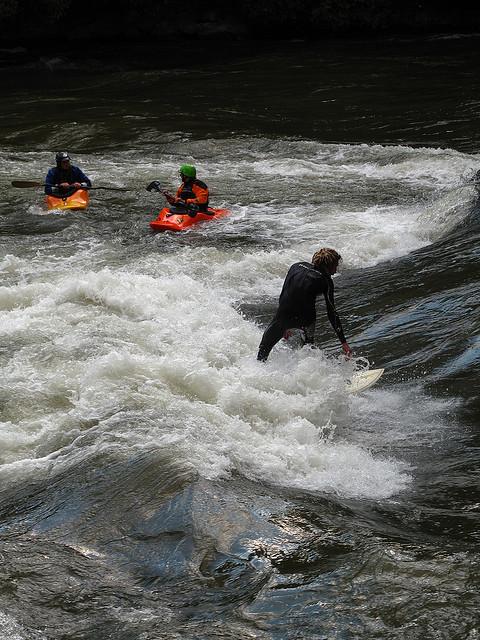What is the man closest to the camera wearing?
Keep it brief. Wetsuit. Is the surfer crazy?
Keep it brief. No. What is on the man's head?
Write a very short answer. Helmet. How many people are sitting in kayaks?
Answer briefly. 2. 